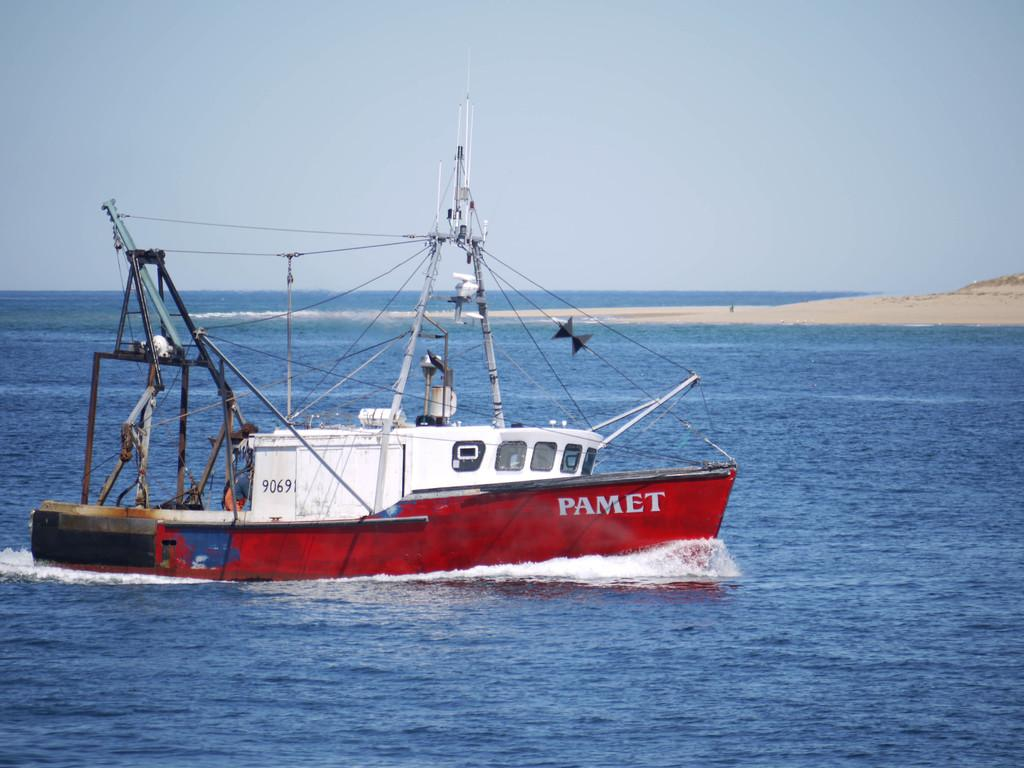What type of setting is depicted in the image? The image is an outside view. What can be seen on the water in the image? There is a boat on the water. What is visible on the right side of the image? The land is visible on the right side of the image. What is visible at the top of the image? The sky is visible at the top of the image. How many sisters are sitting on the boat in the image? There are no sisters present in the image; it only shows a boat on the water. 